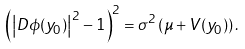<formula> <loc_0><loc_0><loc_500><loc_500>\left ( \left | D \phi ( y _ { 0 } ) \right | ^ { 2 } - 1 \right ) ^ { 2 } = \sigma ^ { 2 } \left ( \mu + V ( y _ { 0 } ) \right ) .</formula> 